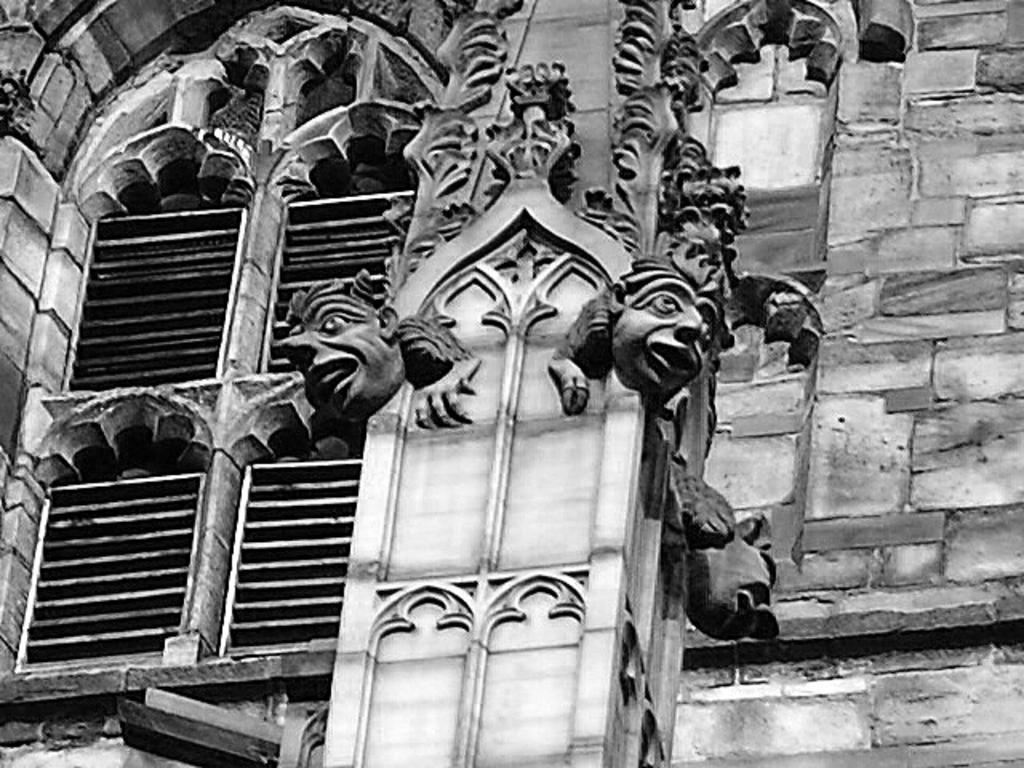In one or two sentences, can you explain what this image depicts? This is a black and white image. Here I can see a wall with some carvings. On the left side there is a window. 